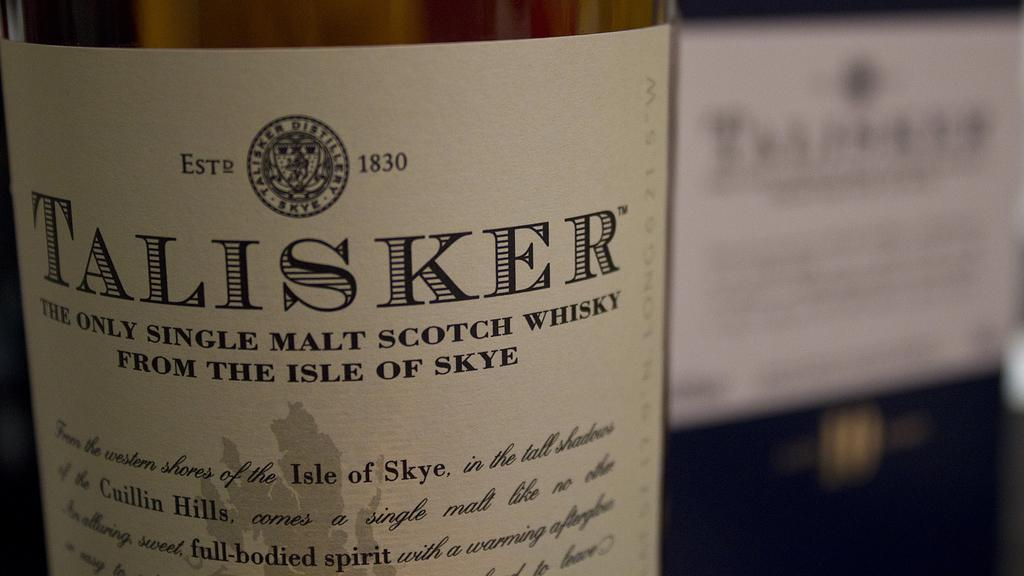<image>
Provide a brief description of the given image. The label of a bottle of Talisker whisky is cream colored with black type. 